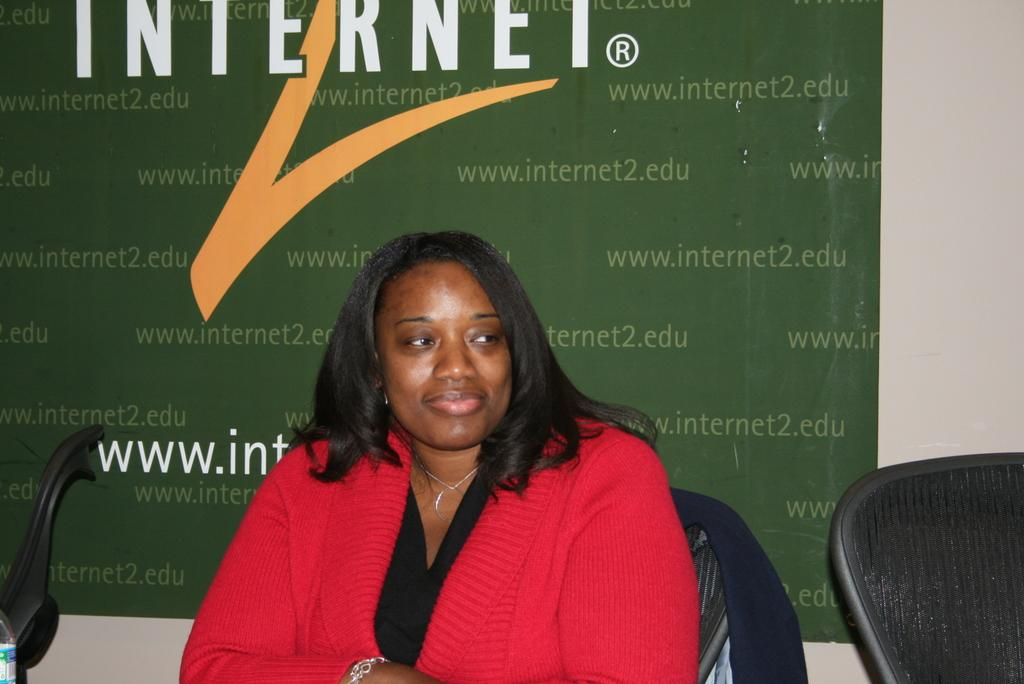What is the woman in the image doing? The woman is seated in the chair. Are there any other chairs visible in the image? Yes, there are chairs on both sides of the woman. What can be seen hanging or displayed in the image? There is a banner with some text in the image. How many pies are being served on the table in the image? There is no table or pies present in the image. What type of waste can be seen in the image? There is no waste visible in the image. 